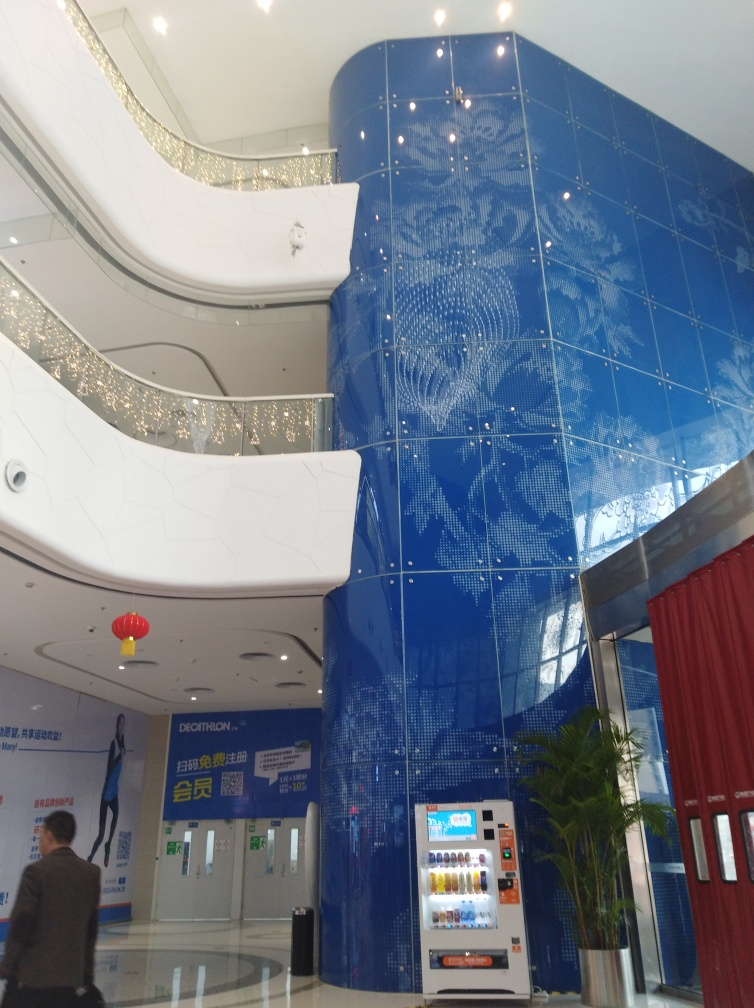How do the lights contribute to the atmosphere of the space? The embedded ceiling lights provide a subtle and elegant ambiance, enhancing the modern aesthetic of the architectural design. The scattered arrangements mirror the stars in the night sky, contributing to an atmosphere of wonder and sophistication within the space. Does the lighting serve a functional purpose as well? Absolutely, beyond the aesthetic function, the lights are designed to provide ample illumination for the interior without creating a harsh glare, ensuring that the space is comfortably lit for visitors to navigate and enjoy the environment. 